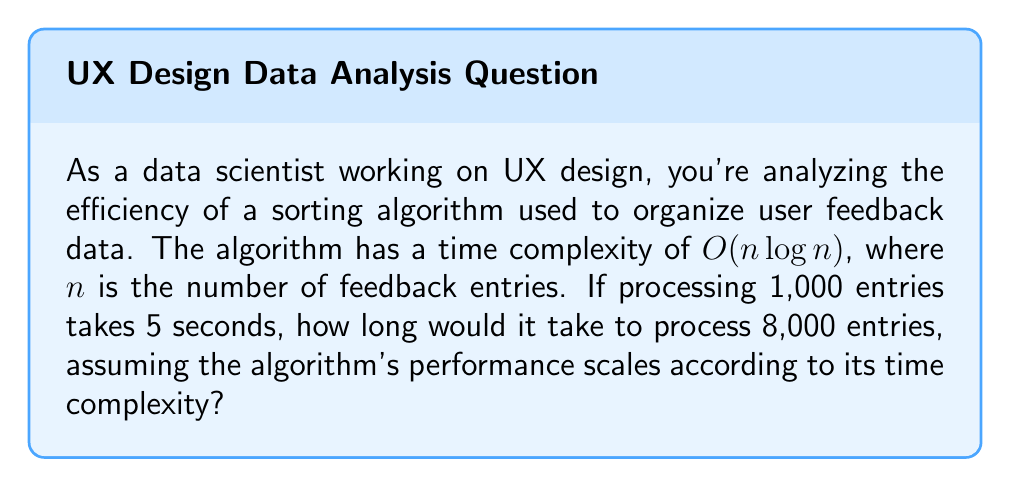Show me your answer to this math problem. To solve this problem, we need to understand how the time complexity $O(n \log n)$ scales with input size. Let's break it down step-by-step:

1) We know that for 1,000 entries ($n_1 = 1000$), the time taken is 5 seconds ($t_1 = 5$).

2) We want to find the time for 8,000 entries ($n_2 = 8000$).

3) The ratio of the time taken for these two input sizes will be proportional to their complexities:

   $$\frac{t_2}{t_1} = \frac{n_2 \log n_2}{n_1 \log n_1}$$

4) Let's substitute the known values:

   $$\frac{t_2}{5} = \frac{8000 \log 8000}{1000 \log 1000}$$

5) Simplify:
   
   $$\frac{t_2}{5} = 8 \cdot \frac{\log 8000}{\log 1000}$$

6) Calculate $\log 8000$ and $\log 1000$:
   
   $$\frac{t_2}{5} = 8 \cdot \frac{3.90309}{3}$$

7) Solve for $t_2$:

   $$t_2 = 5 \cdot 8 \cdot \frac{3.90309}{3} \approx 52.04 \text{ seconds}$$

Therefore, it would take approximately 52.04 seconds to process 8,000 entries.
Answer: 52.04 seconds 